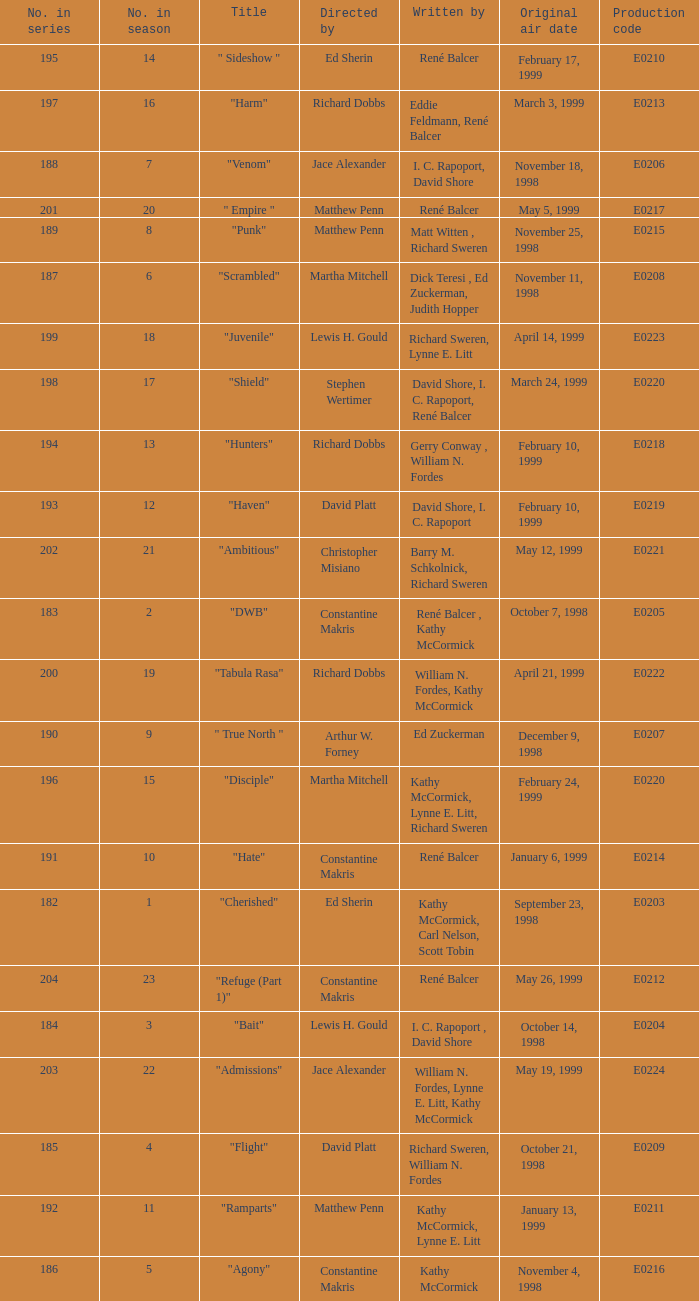The episode with the original air date January 6, 1999, has what production code? E0214. 